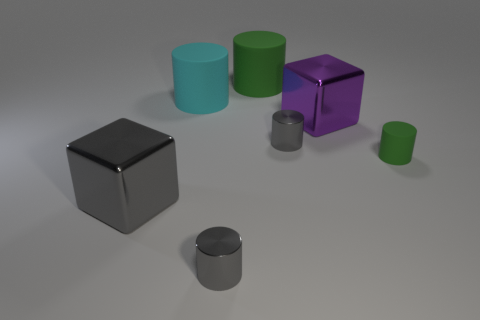Subtract all big cyan matte cylinders. How many cylinders are left? 4 Subtract all purple blocks. How many blocks are left? 1 Subtract all cylinders. How many objects are left? 2 Subtract all small cylinders. Subtract all small green rubber things. How many objects are left? 3 Add 2 cubes. How many cubes are left? 4 Add 4 blocks. How many blocks exist? 6 Add 1 small green cylinders. How many objects exist? 8 Subtract 0 green cubes. How many objects are left? 7 Subtract 1 cubes. How many cubes are left? 1 Subtract all yellow cubes. Subtract all gray cylinders. How many cubes are left? 2 